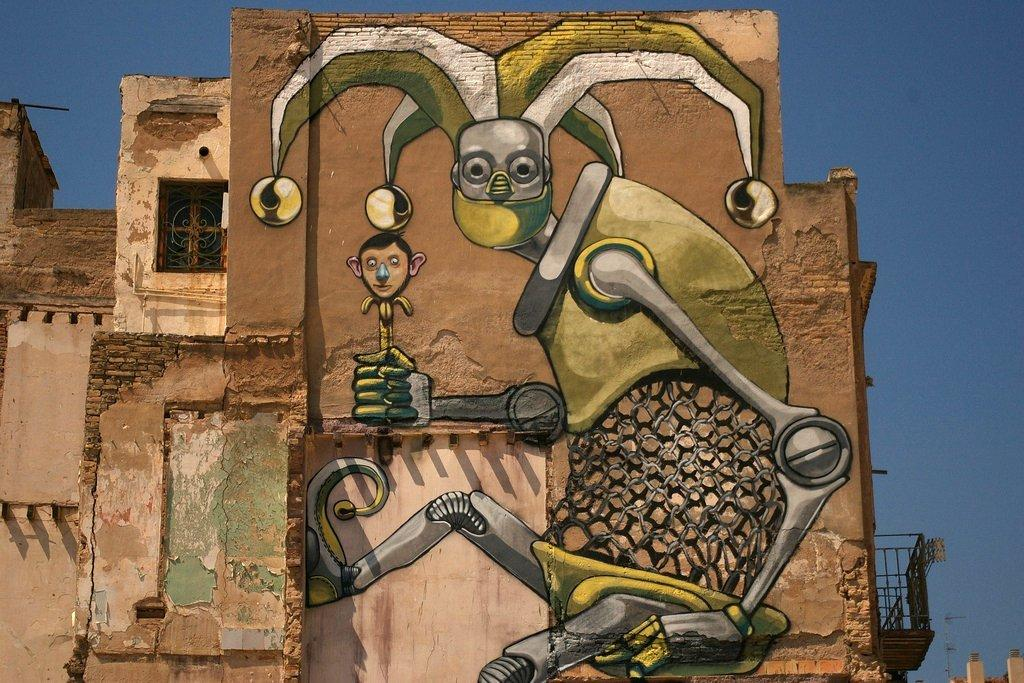What type of structure is present in the image? There is a building in the image. What is featured on the building? There is a painting on the building. Are there any openings in the building? Yes, there is a window on the building. What can be seen in the bottom right corner of the image? There is a wall visible in the bottom right of the image. What is visible at the top of the image? The sky is visible at the top of the image. How many toes can be seen in the image? There are no toes visible in the image. What type of tent is set up in front of the building in the image? There is no tent present in the image; it only features a building with a painting, window, and wall. 